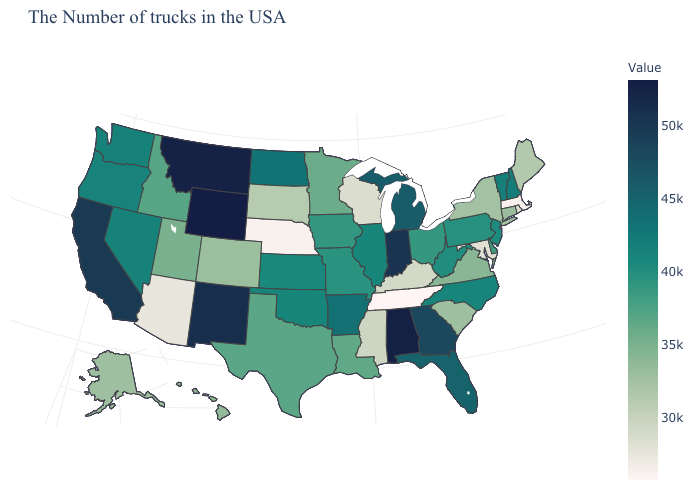Does Pennsylvania have the lowest value in the USA?
Quick response, please. No. Which states have the highest value in the USA?
Give a very brief answer. Wyoming. Is the legend a continuous bar?
Short answer required. Yes. Among the states that border Idaho , which have the highest value?
Quick response, please. Wyoming. Does Wyoming have the highest value in the USA?
Concise answer only. Yes. Which states hav the highest value in the West?
Keep it brief. Wyoming. Among the states that border Tennessee , does Alabama have the highest value?
Quick response, please. Yes. Does Kansas have the highest value in the USA?
Write a very short answer. No. 